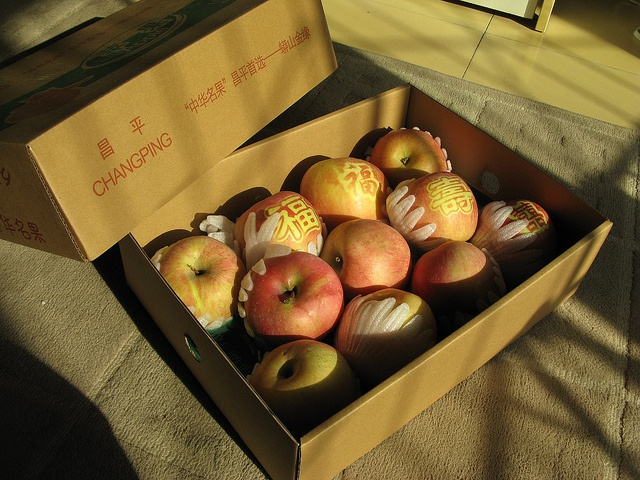Describe the objects in this image and their specific colors. I can see apple in black, brown, maroon, and orange tones, apple in black, maroon, and olive tones, and apple in black, maroon, olive, and brown tones in this image. 